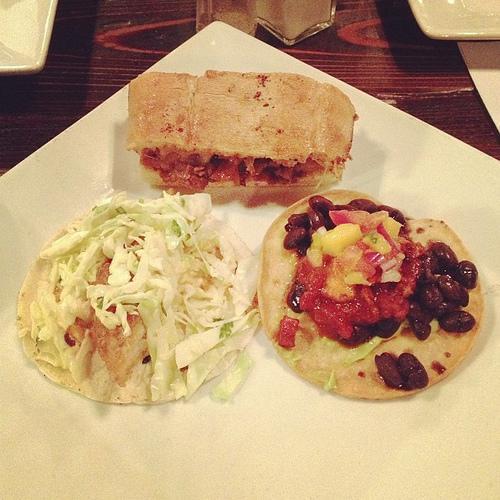How many tortillas are there?
Give a very brief answer. 2. How many food items are there?
Give a very brief answer. 3. 